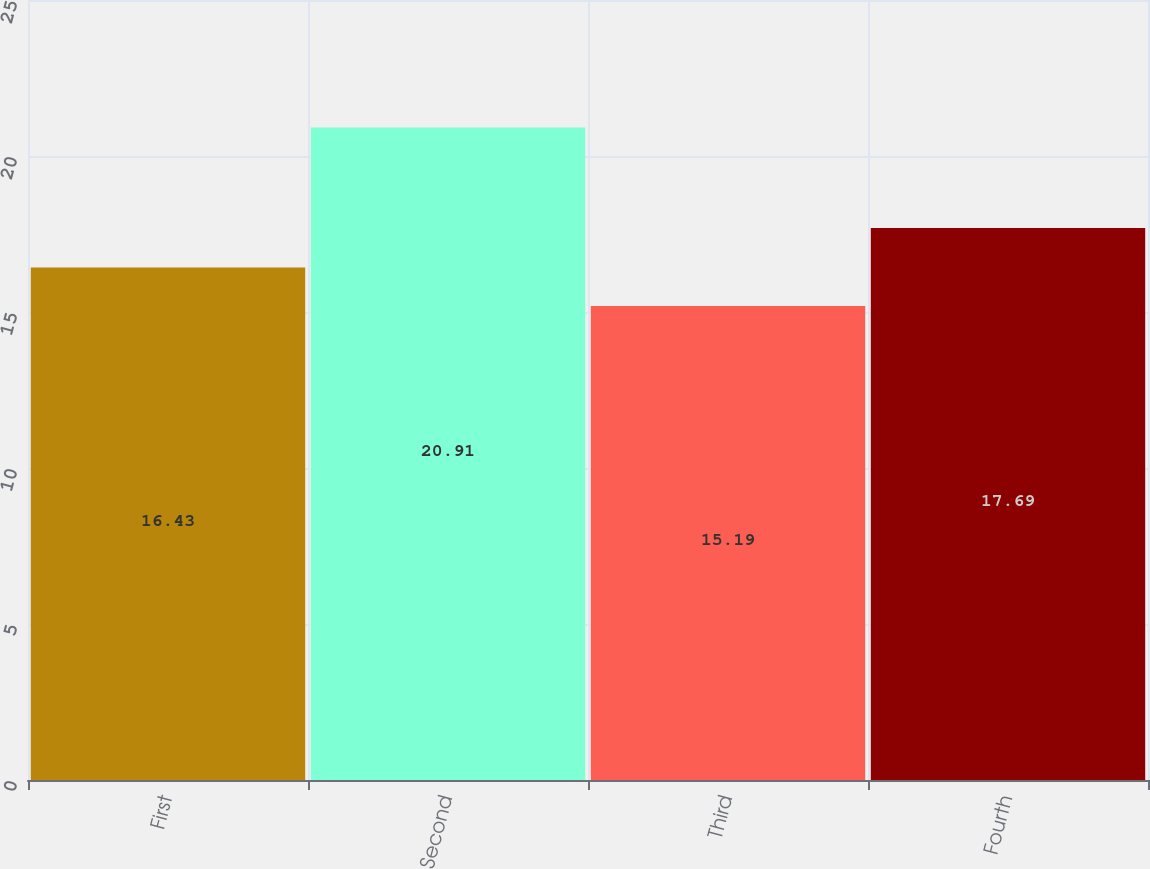<chart> <loc_0><loc_0><loc_500><loc_500><bar_chart><fcel>First<fcel>Second<fcel>Third<fcel>Fourth<nl><fcel>16.43<fcel>20.91<fcel>15.19<fcel>17.69<nl></chart> 